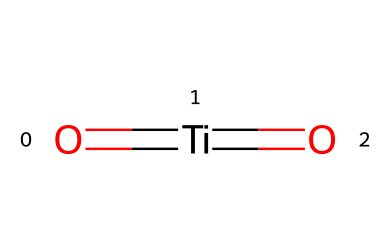What is the central atom in the chemical structure? The provided SMILES shows that titanium is the central atom, as indicated by the "Ti" in the structure.
Answer: titanium How many oxygens are bonded to titanium in this structure? The SMILES representation contains two "O" atoms, indicating there are two oxygen atoms bonded to titanium.
Answer: 2 What type of bonds are present in titanium dioxide? The structural representation contains double bonds between titanium and oxygen, suggesting that the bonds are double bonds (denoted by "=" in the SMILES).
Answer: double bonds Is titanium dioxide nanoparticle hydrophobic or hydrophilic? Given that titanium dioxide is generally known for having hydrophilic properties due to its interactions with water molecules, the reasoning leads to the conclusion that it is hydrophilic.
Answer: hydrophilic What is the oxidation state of titanium in titanium dioxide? In this structure, the titanium atom is bonded to two oxygen atoms, and since oxygen typically has an oxidation state of -2, titanium must have an oxidation state of +4 to balance the overall charge.
Answer: +4 What is the primary function of titanium dioxide nanoparticles in sunscreens? Titanium dioxide nanoparticles mainly serve as a physical UV filter, reflecting and scattering UV radiation to protect the skin from sun damage.
Answer: UV filter What characteristic of titanium dioxide makes it preferable for cosmetic use? Titanium dioxide is favored due to its high refractive index, which enhances its effectiveness in reflecting UV rays and making it suitable for use in cosmetics.
Answer: high refractive index 